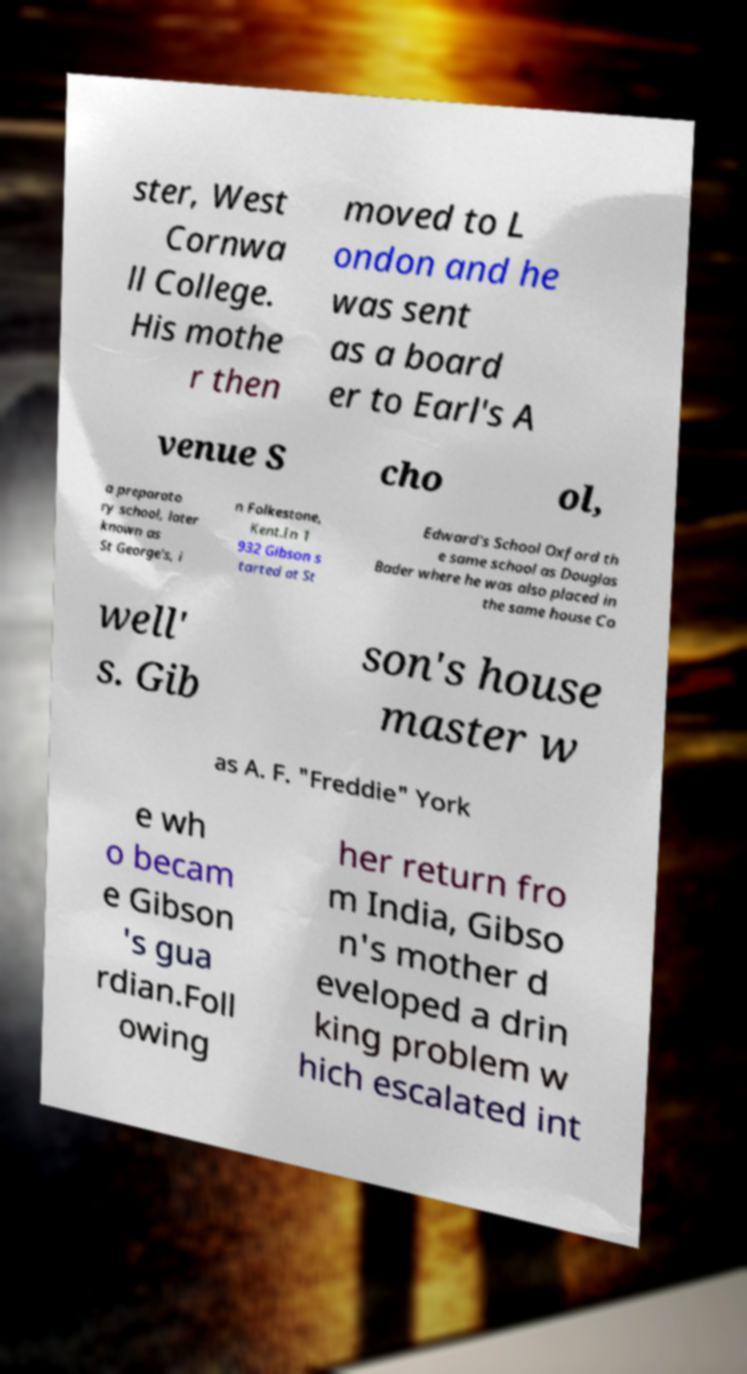Please identify and transcribe the text found in this image. ster, West Cornwa ll College. His mothe r then moved to L ondon and he was sent as a board er to Earl's A venue S cho ol, a preparato ry school, later known as St George's, i n Folkestone, Kent.In 1 932 Gibson s tarted at St Edward's School Oxford th e same school as Douglas Bader where he was also placed in the same house Co well' s. Gib son's house master w as A. F. "Freddie" York e wh o becam e Gibson 's gua rdian.Foll owing her return fro m India, Gibso n's mother d eveloped a drin king problem w hich escalated int 